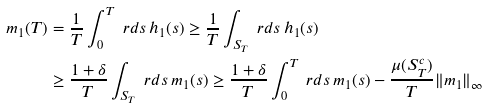Convert formula to latex. <formula><loc_0><loc_0><loc_500><loc_500>m _ { 1 } ( T ) & = \frac { 1 } { T } \int _ { 0 } ^ { T } \ r d s \, h _ { 1 } ( s ) \geq \frac { 1 } { T } \int _ { S _ { T } } \ r d s \, h _ { 1 } ( s ) \\ & \geq \frac { 1 + \delta } { T } \int _ { S _ { T } } \ r d s \, m _ { 1 } ( s ) \geq \frac { 1 + \delta } { T } \int _ { 0 } ^ { T } \ r d s \, m _ { 1 } ( s ) - \frac { \mu ( S _ { T } ^ { c } ) } { T } \| m _ { 1 } \| _ { \infty }</formula> 